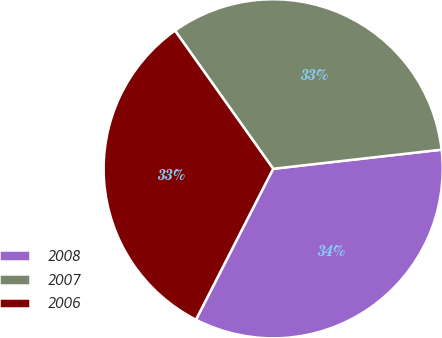Convert chart to OTSL. <chart><loc_0><loc_0><loc_500><loc_500><pie_chart><fcel>2008<fcel>2007<fcel>2006<nl><fcel>34.33%<fcel>33.03%<fcel>32.64%<nl></chart> 